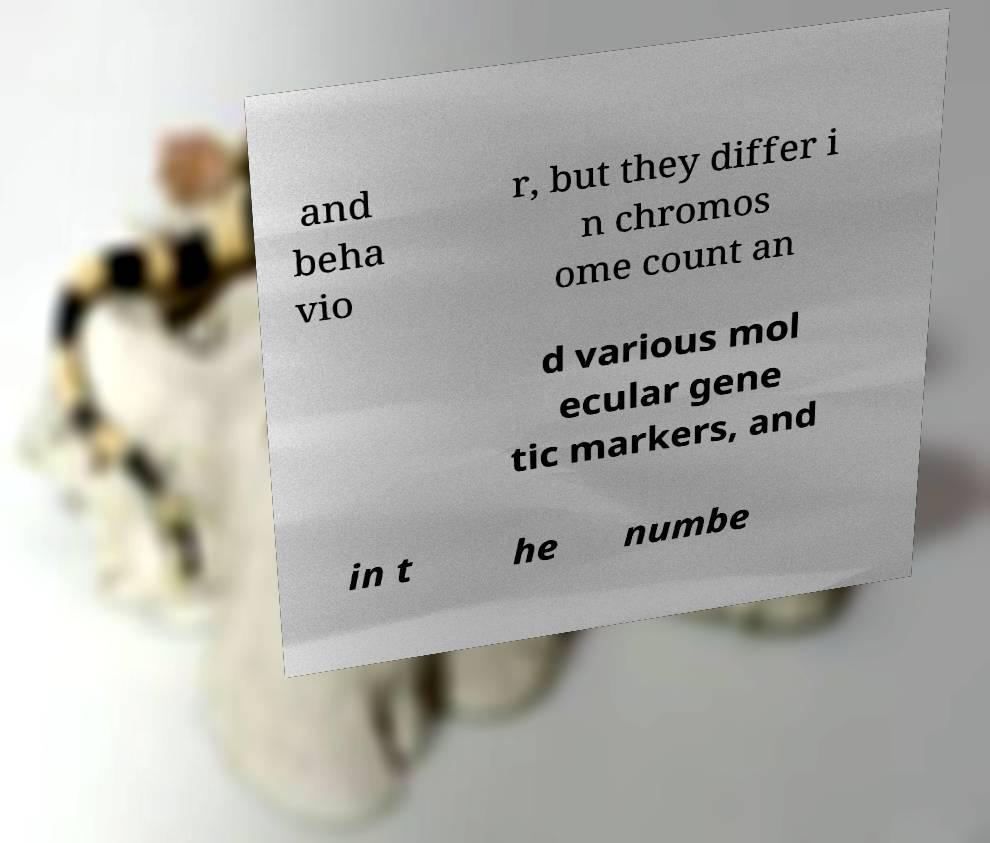For documentation purposes, I need the text within this image transcribed. Could you provide that? and beha vio r, but they differ i n chromos ome count an d various mol ecular gene tic markers, and in t he numbe 